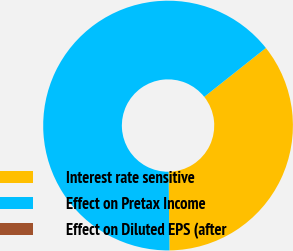Convert chart. <chart><loc_0><loc_0><loc_500><loc_500><pie_chart><fcel>Interest rate sensitive<fcel>Effect on Pretax Income<fcel>Effect on Diluted EPS (after<nl><fcel>35.49%<fcel>64.51%<fcel>0.0%<nl></chart> 